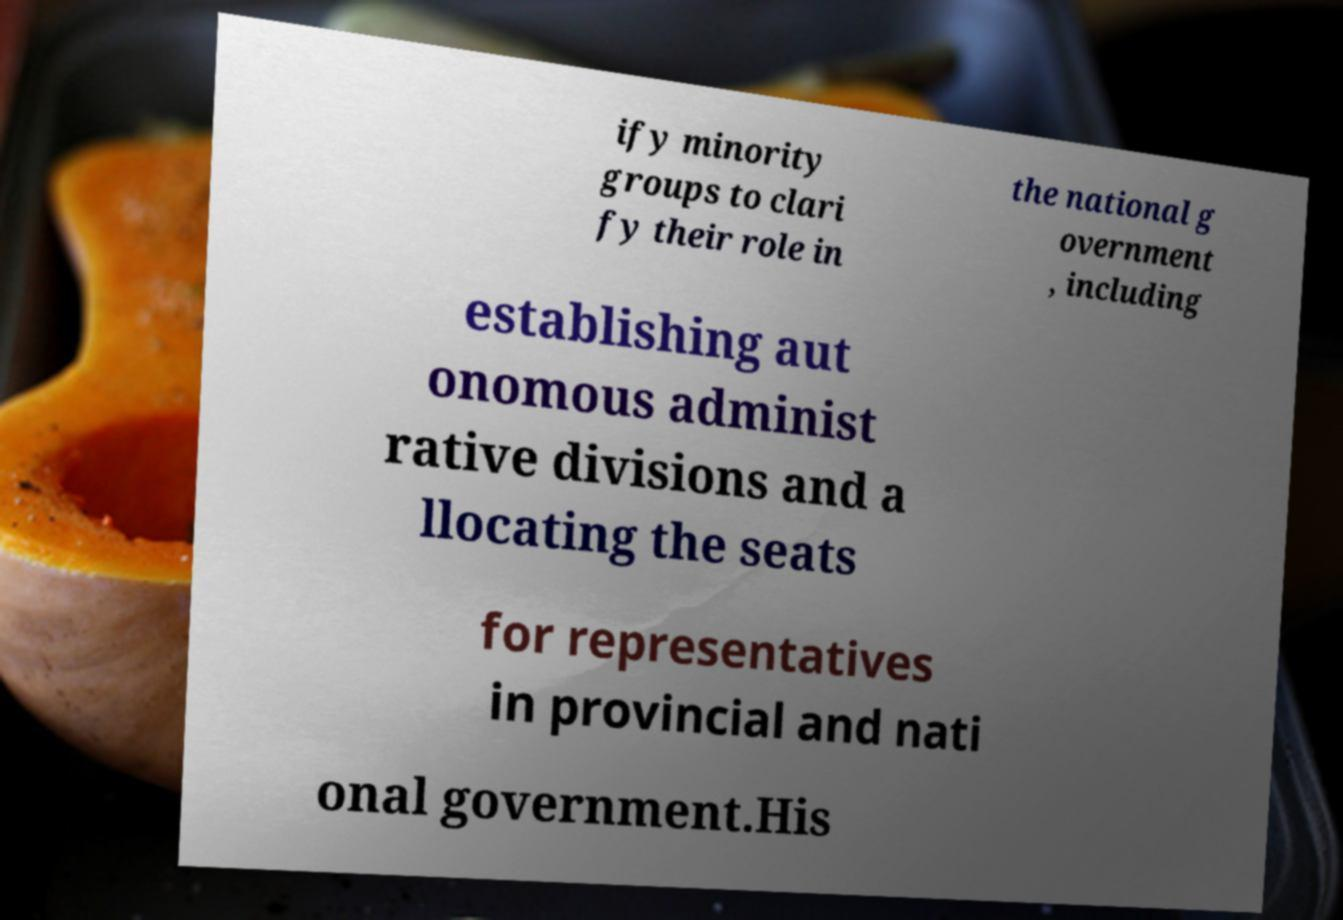There's text embedded in this image that I need extracted. Can you transcribe it verbatim? ify minority groups to clari fy their role in the national g overnment , including establishing aut onomous administ rative divisions and a llocating the seats for representatives in provincial and nati onal government.His 